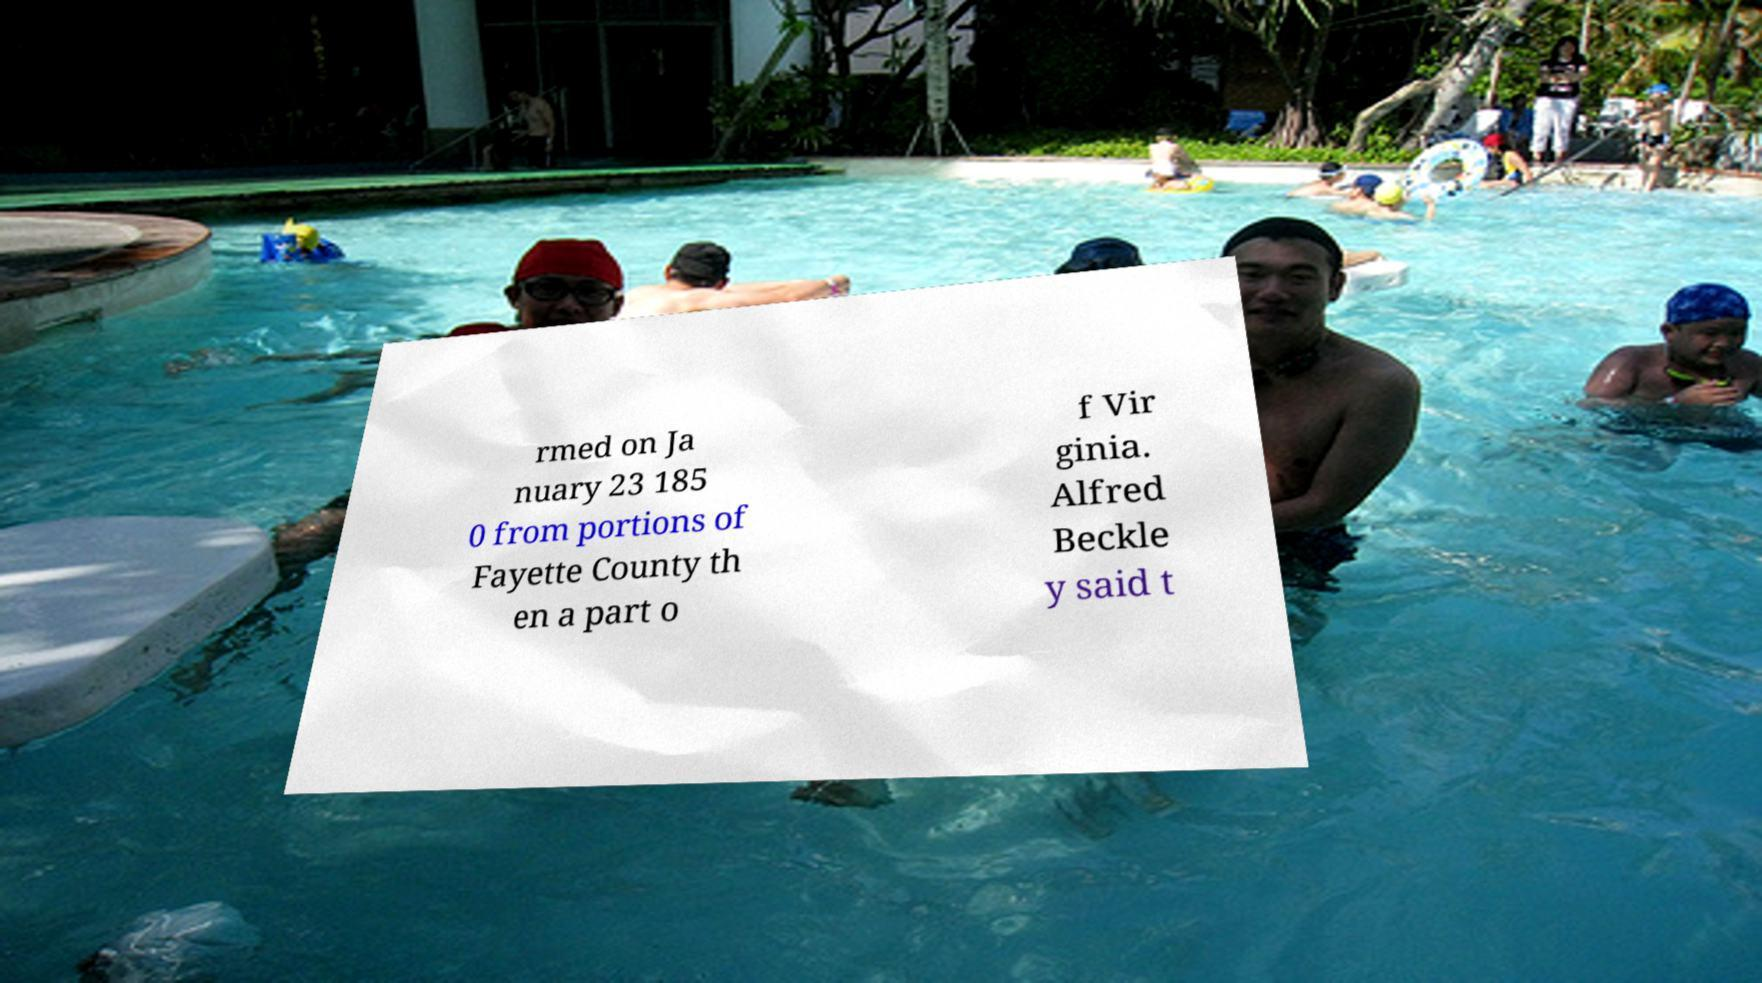Can you accurately transcribe the text from the provided image for me? rmed on Ja nuary 23 185 0 from portions of Fayette County th en a part o f Vir ginia. Alfred Beckle y said t 